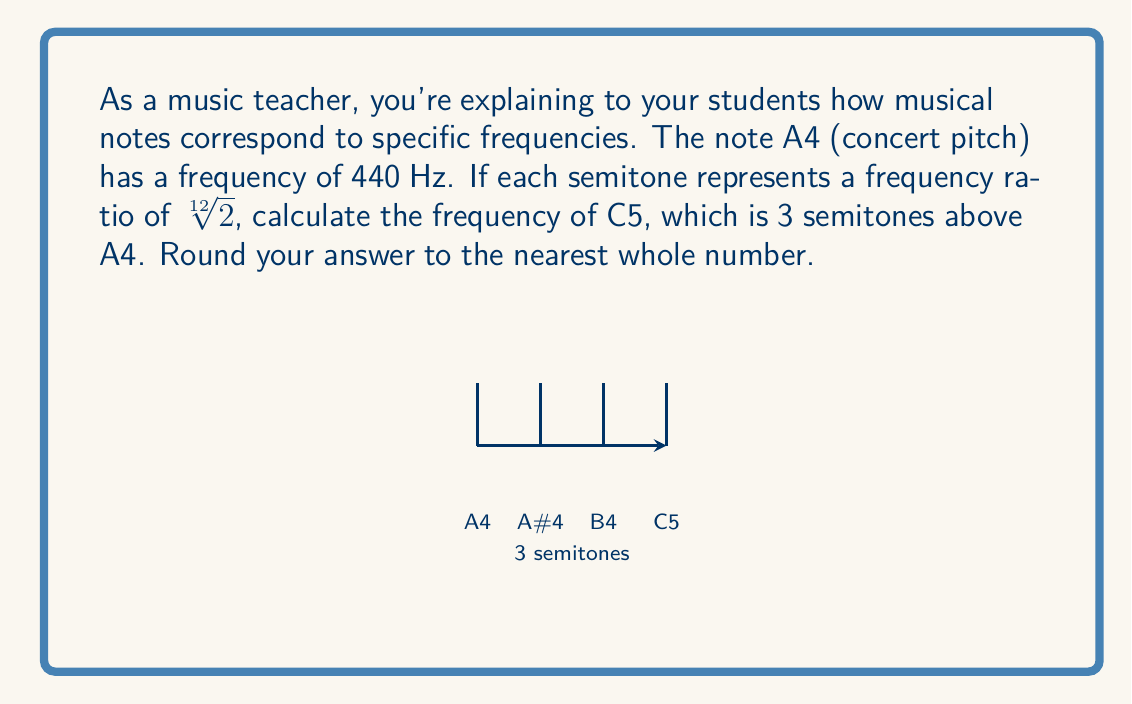Can you solve this math problem? Let's approach this step-by-step:

1) The frequency ratio between each semitone is $\sqrt[12]{2}$.

2) C5 is 3 semitones above A4, so we need to multiply the frequency of A4 by $(\sqrt[12]{2})^3$.

3) Let's set up the equation:
   $$f_{C5} = 440 \cdot (\sqrt[12]{2})^3$$

4) First, let's calculate $(\sqrt[12]{2})^3$:
   $$(\sqrt[12]{2})^3 = 2^{3/12} = 2^{1/4} \approx 1.1892$$

5) Now, let's multiply this by 440:
   $$f_{C5} = 440 \cdot 1.1892 \approx 523.2516$$

6) Rounding to the nearest whole number:
   $$f_{C5} \approx 523 \text{ Hz}$$

This method demonstrates how we can use the properties of exponentials to calculate frequencies of notes, a valuable skill in music theory and acoustics.
Answer: 523 Hz 